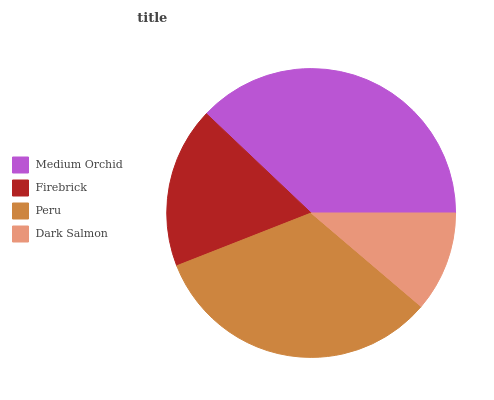Is Dark Salmon the minimum?
Answer yes or no. Yes. Is Medium Orchid the maximum?
Answer yes or no. Yes. Is Firebrick the minimum?
Answer yes or no. No. Is Firebrick the maximum?
Answer yes or no. No. Is Medium Orchid greater than Firebrick?
Answer yes or no. Yes. Is Firebrick less than Medium Orchid?
Answer yes or no. Yes. Is Firebrick greater than Medium Orchid?
Answer yes or no. No. Is Medium Orchid less than Firebrick?
Answer yes or no. No. Is Peru the high median?
Answer yes or no. Yes. Is Firebrick the low median?
Answer yes or no. Yes. Is Dark Salmon the high median?
Answer yes or no. No. Is Dark Salmon the low median?
Answer yes or no. No. 